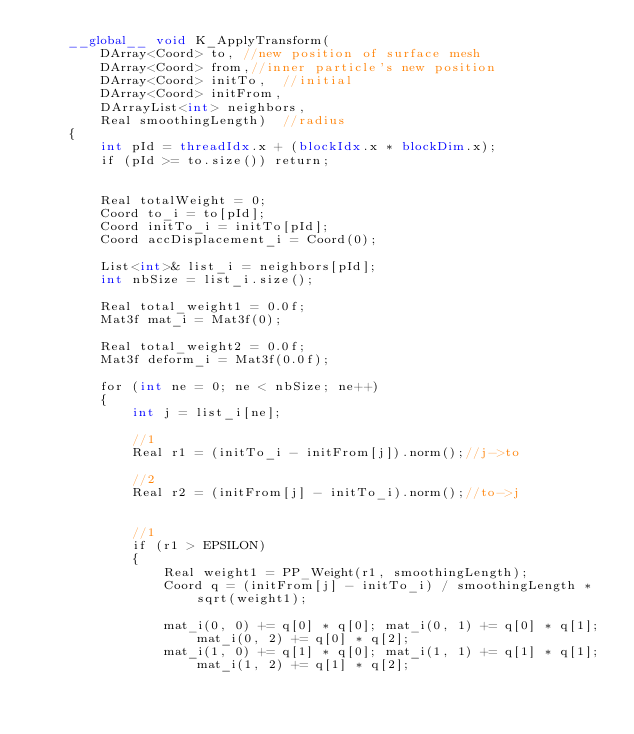<code> <loc_0><loc_0><loc_500><loc_500><_Cuda_>	__global__ void K_ApplyTransform(
		DArray<Coord> to, //new position of surface mesh
		DArray<Coord> from,//inner particle's new position
		DArray<Coord> initTo,  //initial
		DArray<Coord> initFrom,
		DArrayList<int> neighbors,
		Real smoothingLength)  //radius
	{
		int pId = threadIdx.x + (blockIdx.x * blockDim.x);
		if (pId >= to.size()) return;


		Real totalWeight = 0;
		Coord to_i = to[pId];
		Coord initTo_i = initTo[pId];
		Coord accDisplacement_i = Coord(0);

		List<int>& list_i = neighbors[pId];
		int nbSize = list_i.size();

		Real total_weight1 = 0.0f;
		Mat3f mat_i = Mat3f(0);

		Real total_weight2 = 0.0f;
		Mat3f deform_i = Mat3f(0.0f);

		for (int ne = 0; ne < nbSize; ne++)
		{
			int j = list_i[ne];

			//1
			Real r1 = (initTo_i - initFrom[j]).norm();//j->to

			//2
			Real r2 = (initFrom[j] - initTo_i).norm();//to->j


			//1
			if (r1 > EPSILON)
			{
				Real weight1 = PP_Weight(r1, smoothingLength);
				Coord q = (initFrom[j] - initTo_i) / smoothingLength * sqrt(weight1);

				mat_i(0, 0) += q[0] * q[0]; mat_i(0, 1) += q[0] * q[1]; mat_i(0, 2) += q[0] * q[2];
				mat_i(1, 0) += q[1] * q[0]; mat_i(1, 1) += q[1] * q[1]; mat_i(1, 2) += q[1] * q[2];</code> 